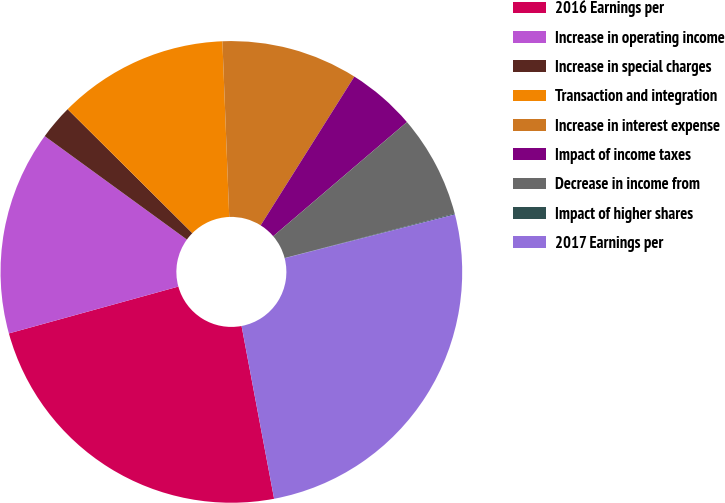Convert chart to OTSL. <chart><loc_0><loc_0><loc_500><loc_500><pie_chart><fcel>2016 Earnings per<fcel>Increase in operating income<fcel>Increase in special charges<fcel>Transaction and integration<fcel>Increase in interest expense<fcel>Impact of income taxes<fcel>Decrease in income from<fcel>Impact of higher shares<fcel>2017 Earnings per<nl><fcel>23.67%<fcel>14.3%<fcel>2.44%<fcel>11.93%<fcel>9.56%<fcel>4.81%<fcel>7.18%<fcel>0.06%<fcel>26.04%<nl></chart> 